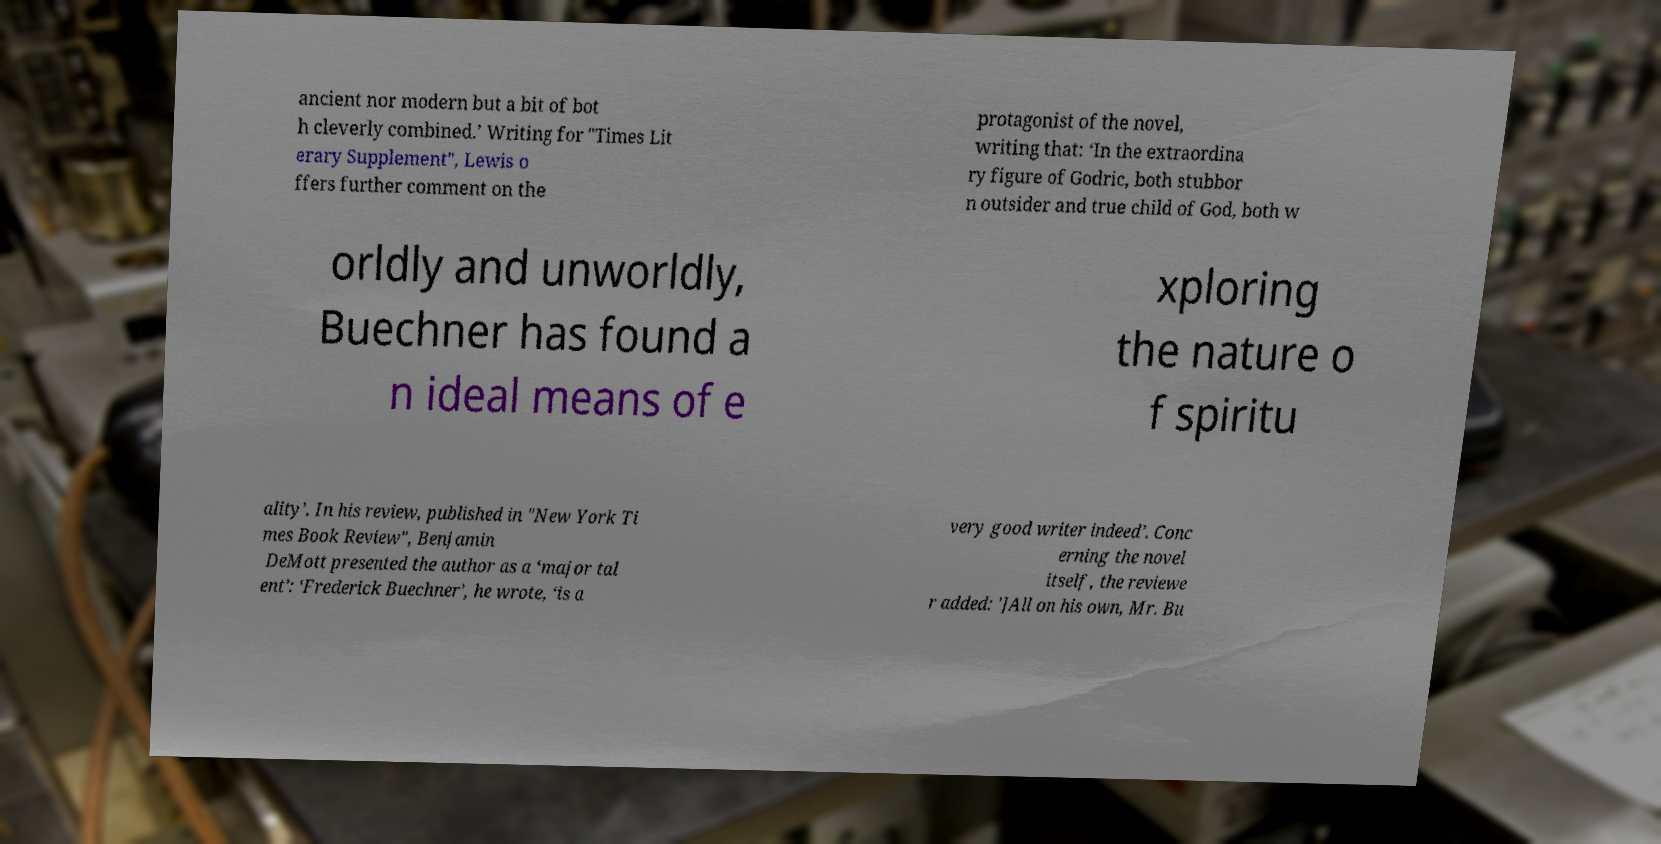I need the written content from this picture converted into text. Can you do that? ancient nor modern but a bit of bot h cleverly combined.’ Writing for "Times Lit erary Supplement", Lewis o ffers further comment on the protagonist of the novel, writing that: ‘In the extraordina ry figure of Godric, both stubbor n outsider and true child of God, both w orldly and unworldly, Buechner has found a n ideal means of e xploring the nature o f spiritu ality’. In his review, published in "New York Ti mes Book Review", Benjamin DeMott presented the author as a ‘major tal ent’: ‘Frederick Buechner’, he wrote, ‘is a very good writer indeed’. Conc erning the novel itself, the reviewe r added: ']All on his own, Mr. Bu 